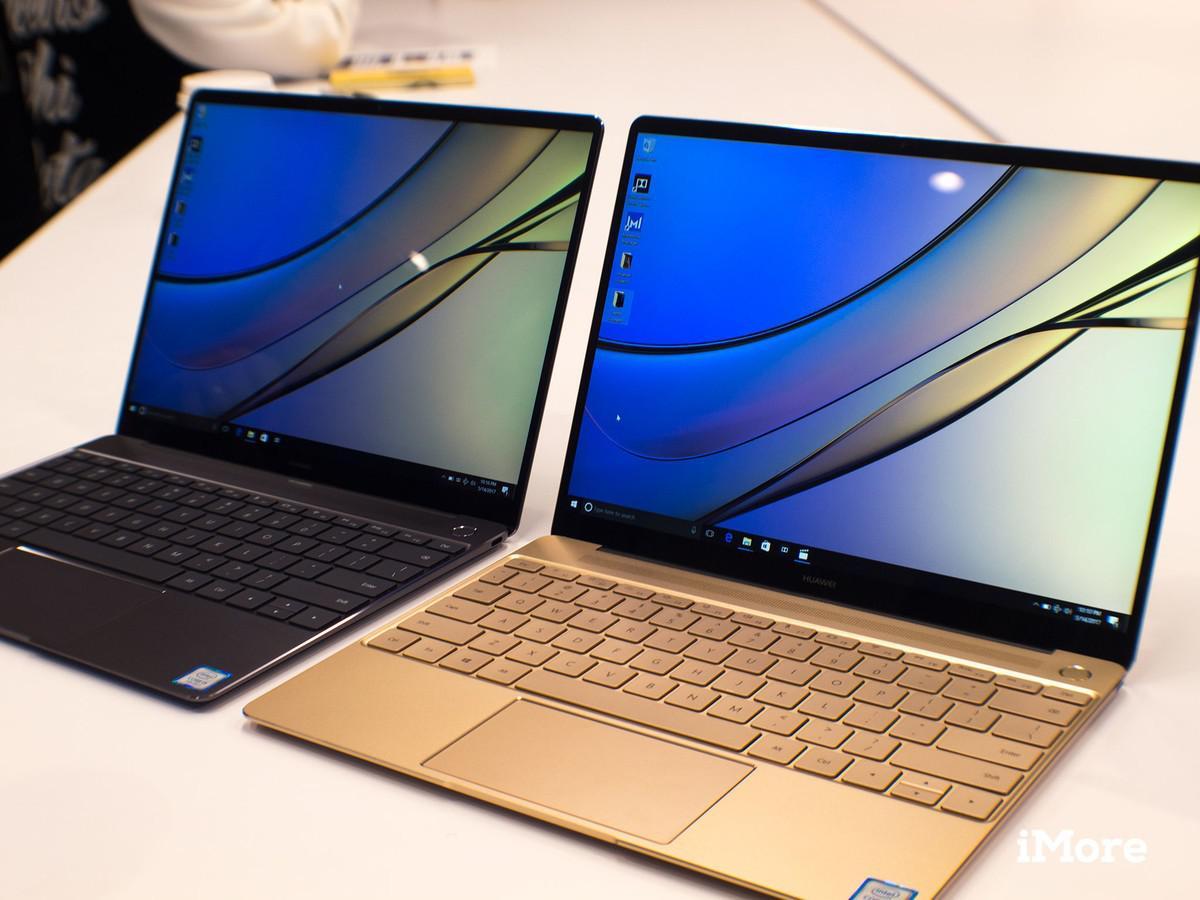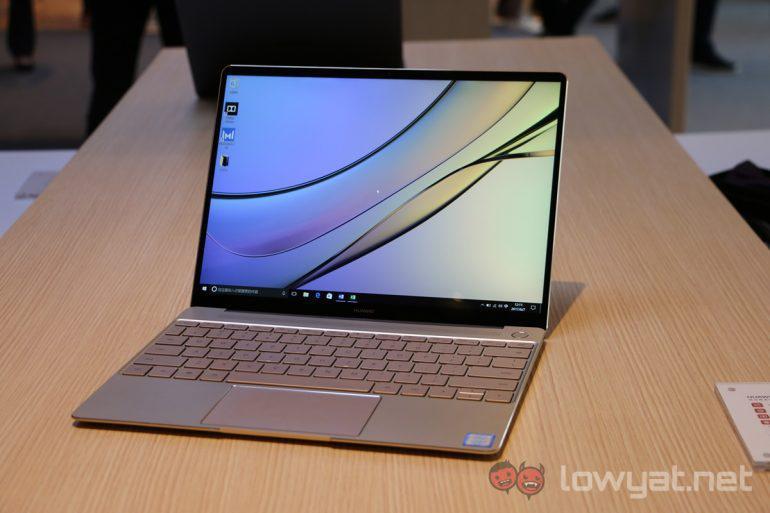The first image is the image on the left, the second image is the image on the right. Assess this claim about the two images: "One image shows side-by-side open laptops and the other shows a single open laptop, and all laptops are angled somewhat leftward and display curving lines on the screen.". Correct or not? Answer yes or no. Yes. The first image is the image on the left, the second image is the image on the right. Examine the images to the left and right. Is the description "All the desktops have the same design." accurate? Answer yes or no. Yes. 